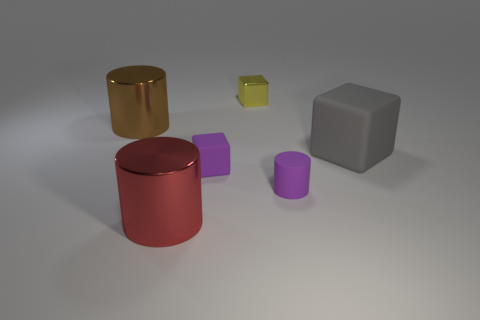Subtract all green cubes. Subtract all blue balls. How many cubes are left? 3 Add 2 big yellow metallic things. How many objects exist? 8 Add 6 tiny purple things. How many tiny purple things are left? 8 Add 5 small cyan cubes. How many small cyan cubes exist? 5 Subtract 0 cyan spheres. How many objects are left? 6 Subtract all large brown cylinders. Subtract all gray blocks. How many objects are left? 4 